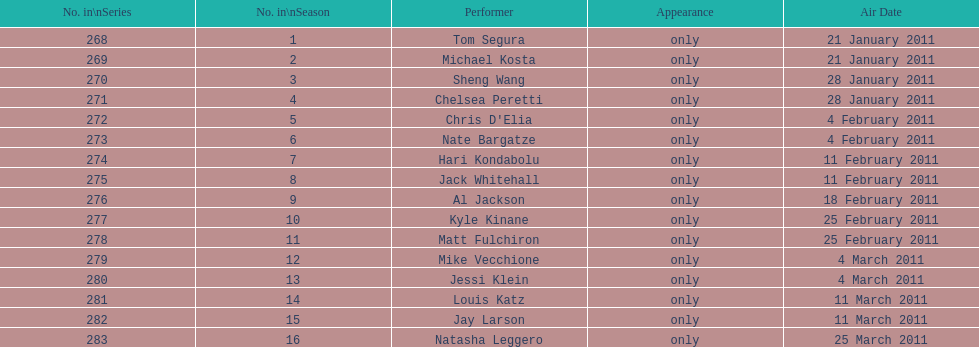Could you help me parse every detail presented in this table? {'header': ['No. in\\nSeries', 'No. in\\nSeason', 'Performer', 'Appearance', 'Air Date'], 'rows': [['268', '1', 'Tom Segura', 'only', '21 January 2011'], ['269', '2', 'Michael Kosta', 'only', '21 January 2011'], ['270', '3', 'Sheng Wang', 'only', '28 January 2011'], ['271', '4', 'Chelsea Peretti', 'only', '28 January 2011'], ['272', '5', "Chris D'Elia", 'only', '4 February 2011'], ['273', '6', 'Nate Bargatze', 'only', '4 February 2011'], ['274', '7', 'Hari Kondabolu', 'only', '11 February 2011'], ['275', '8', 'Jack Whitehall', 'only', '11 February 2011'], ['276', '9', 'Al Jackson', 'only', '18 February 2011'], ['277', '10', 'Kyle Kinane', 'only', '25 February 2011'], ['278', '11', 'Matt Fulchiron', 'only', '25 February 2011'], ['279', '12', 'Mike Vecchione', 'only', '4 March 2011'], ['280', '13', 'Jessi Klein', 'only', '4 March 2011'], ['281', '14', 'Louis Katz', 'only', '11 March 2011'], ['282', '15', 'Jay Larson', 'only', '11 March 2011'], ['283', '16', 'Natasha Leggero', 'only', '25 March 2011']]} Who made their initial appearance first, tom segura or jay larson? Tom Segura. 